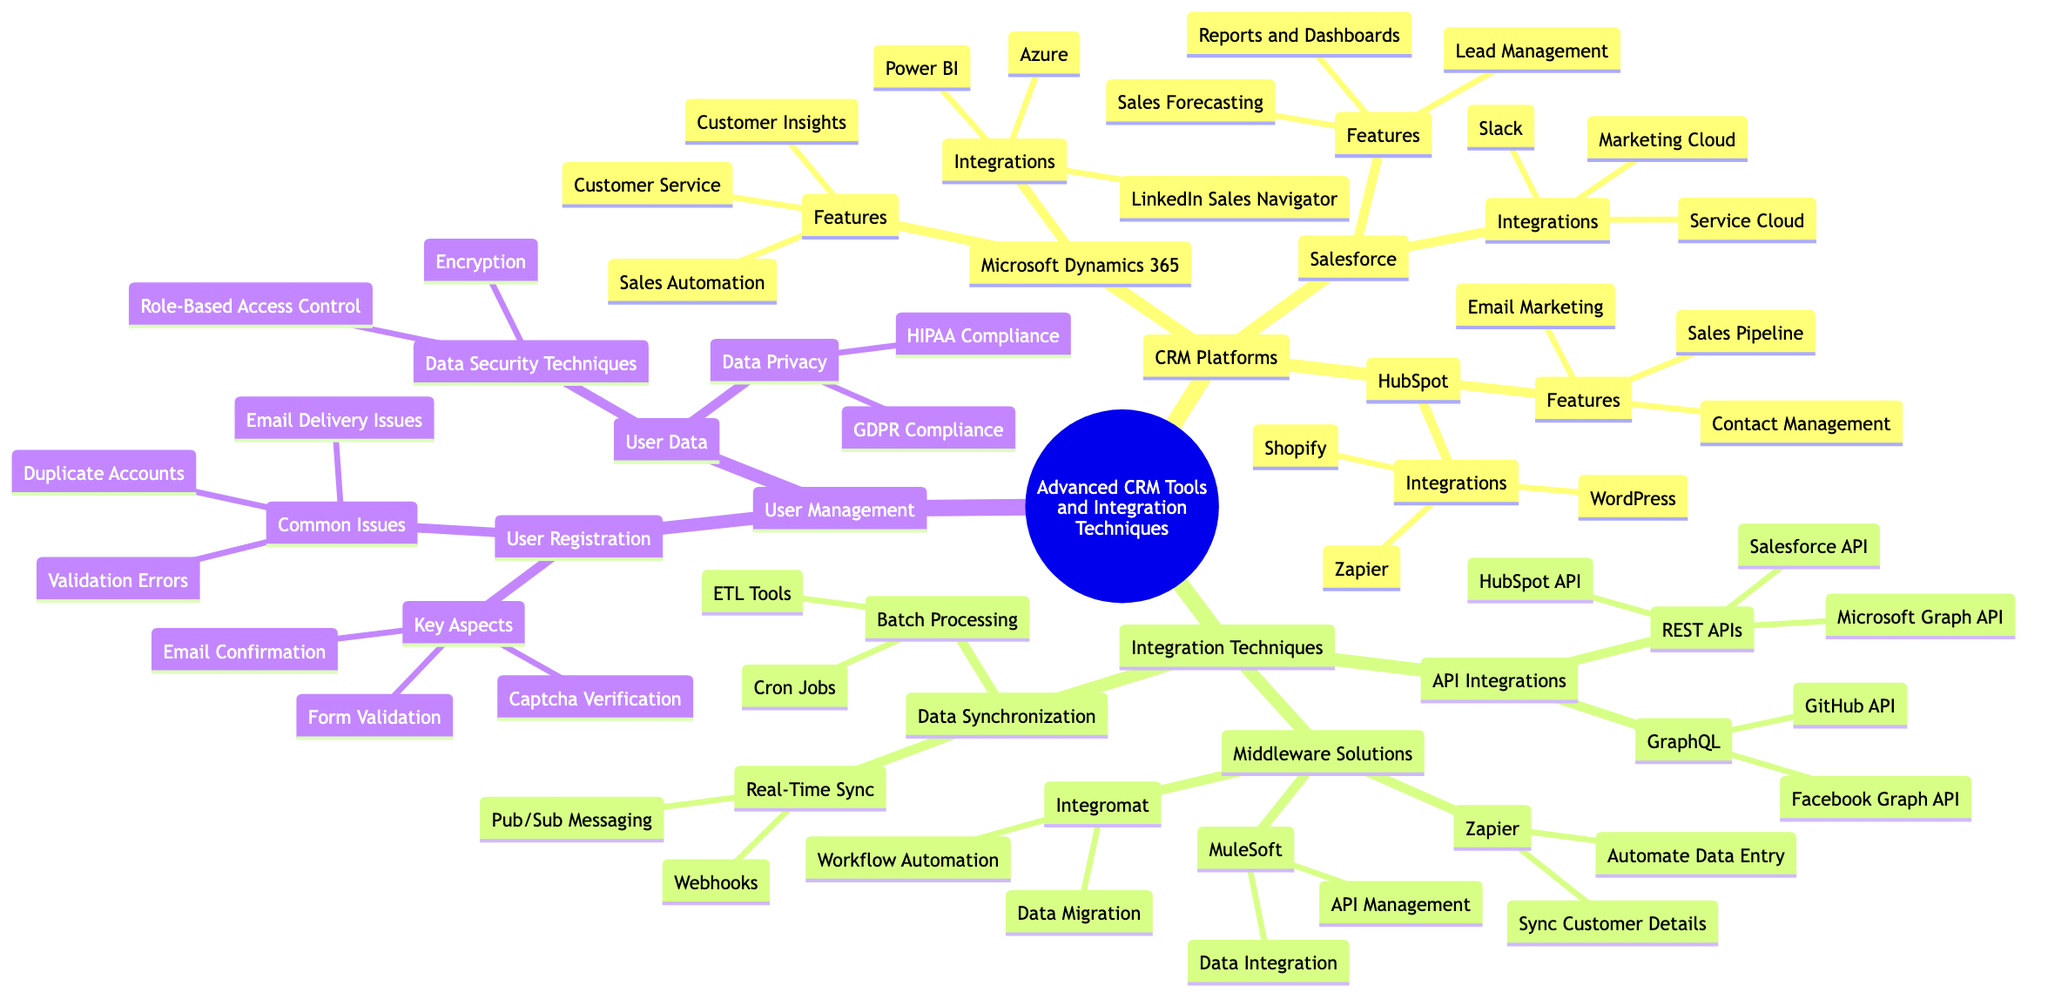What are the CRM platforms listed in the diagram? The diagram identifies three CRM platforms under the "CRM Platforms" node: Salesforce, HubSpot, and Microsoft Dynamics 365.
Answer: Salesforce, HubSpot, Microsoft Dynamics 365 How many features does Microsoft Dynamics 365 have? In the diagram, Microsoft Dynamics 365 has three features specified: Customer Insights, Sales Automation, and Customer Service.
Answer: Three What is a middleware solution mentioned in the diagram? The diagram lists three middleware solutions: Zapier, MuleSoft, and Integromat. Therefore, one example can be taken from any of these three listed.
Answer: Zapier Which integration technique involves Webhooks? Under the "Data Synchronization" node and its "Real-Time Sync" sub-node, the diagram explicitly mentions Webhooks as a method of real-time synchronization.
Answer: Webhooks Which CRM platform integrates with Slack? The diagram indicates that Salesforce has an integration with Slack among its integrations listed under the "Integrations" section.
Answer: Salesforce How many common issues are identified in User Registration? The User Registration section specifies three common issues: Duplicate Accounts, Validation Errors, and Email Delivery Issues. Thus, a count yields three.
Answer: Three Which API is associated with HubSpot? Within the "REST APIs" under the "API Integrations" section, the diagram lists the HubSpot API, indicating its association with the HubSpot platform.
Answer: HubSpot API What is a use case for Integromat? Under the "Middleware Solutions" section for Integromat, the use cases specified include Workflow Automation and Data Migration. Therefore, a use case would be Workflow Automation.
Answer: Workflow Automation Which data privacy compliance is mentioned? In the "User Data" section under "Data Privacy," the diagram specifies two compliance types: GDPR Compliance and HIPAA Compliance. A correct response can be any of these.
Answer: GDPR Compliance 